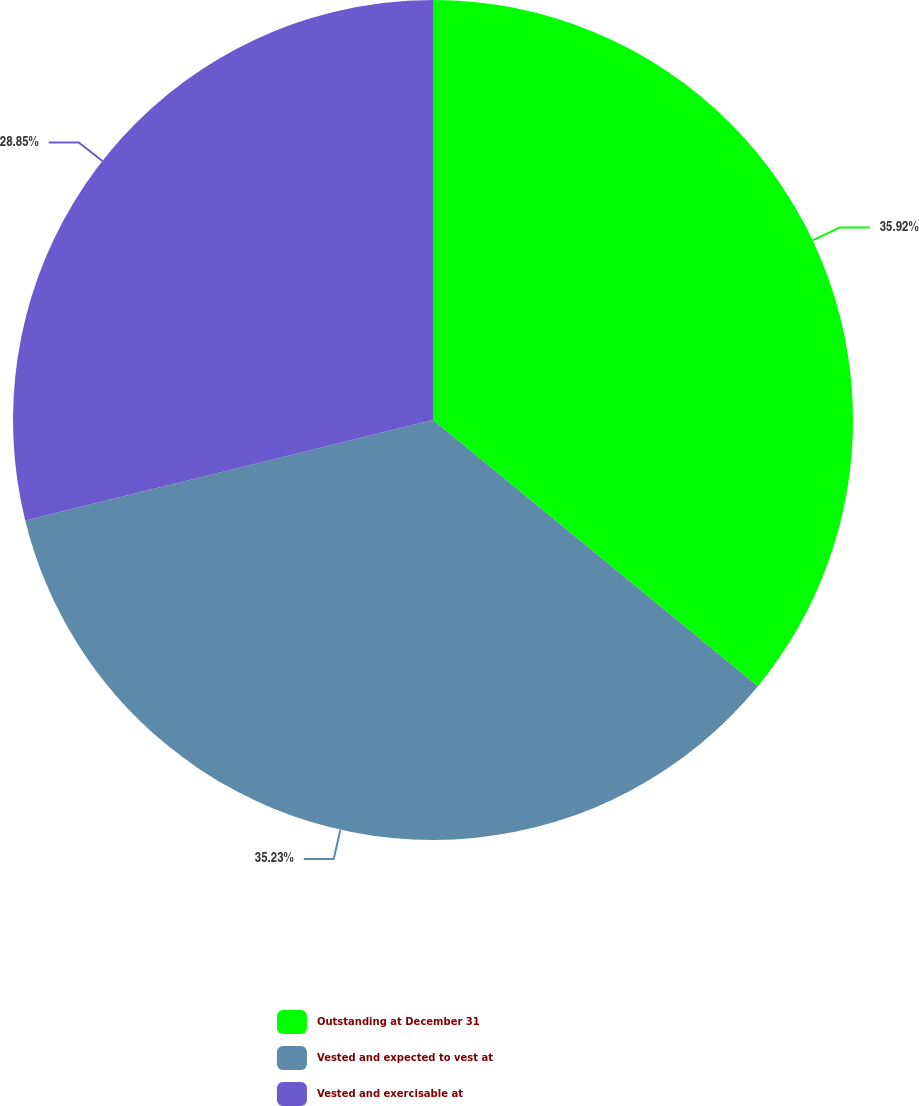Convert chart to OTSL. <chart><loc_0><loc_0><loc_500><loc_500><pie_chart><fcel>Outstanding at December 31<fcel>Vested and expected to vest at<fcel>Vested and exercisable at<nl><fcel>35.93%<fcel>35.23%<fcel>28.85%<nl></chart> 